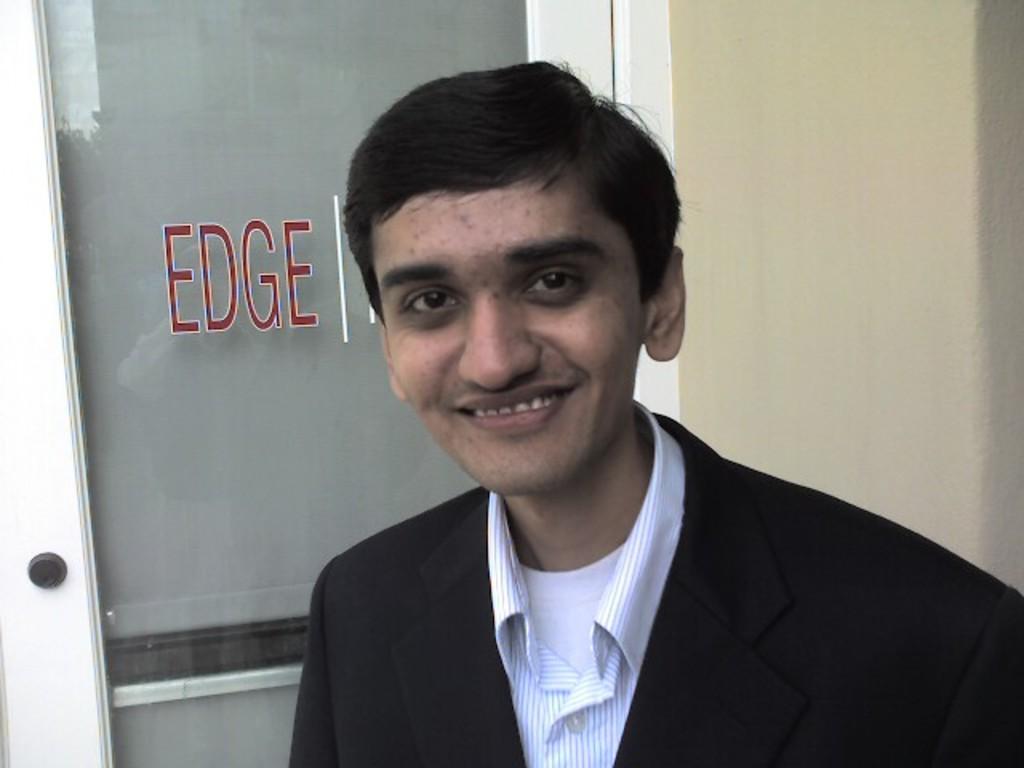Could you give a brief overview of what you see in this image? In this picture we can see a man smiling here, on the left side there is a door, we can see some text here, in the background there is a wall. 